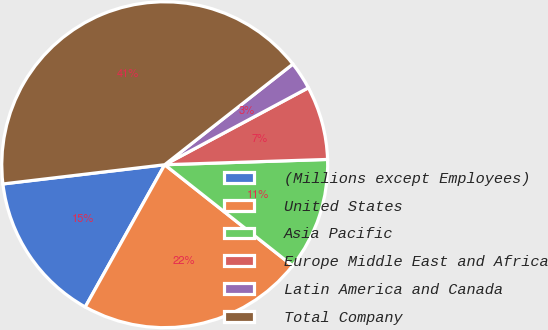Convert chart to OTSL. <chart><loc_0><loc_0><loc_500><loc_500><pie_chart><fcel>(Millions except Employees)<fcel>United States<fcel>Asia Pacific<fcel>Europe Middle East and Africa<fcel>Latin America and Canada<fcel>Total Company<nl><fcel>15.01%<fcel>22.47%<fcel>11.16%<fcel>7.31%<fcel>2.77%<fcel>41.29%<nl></chart> 